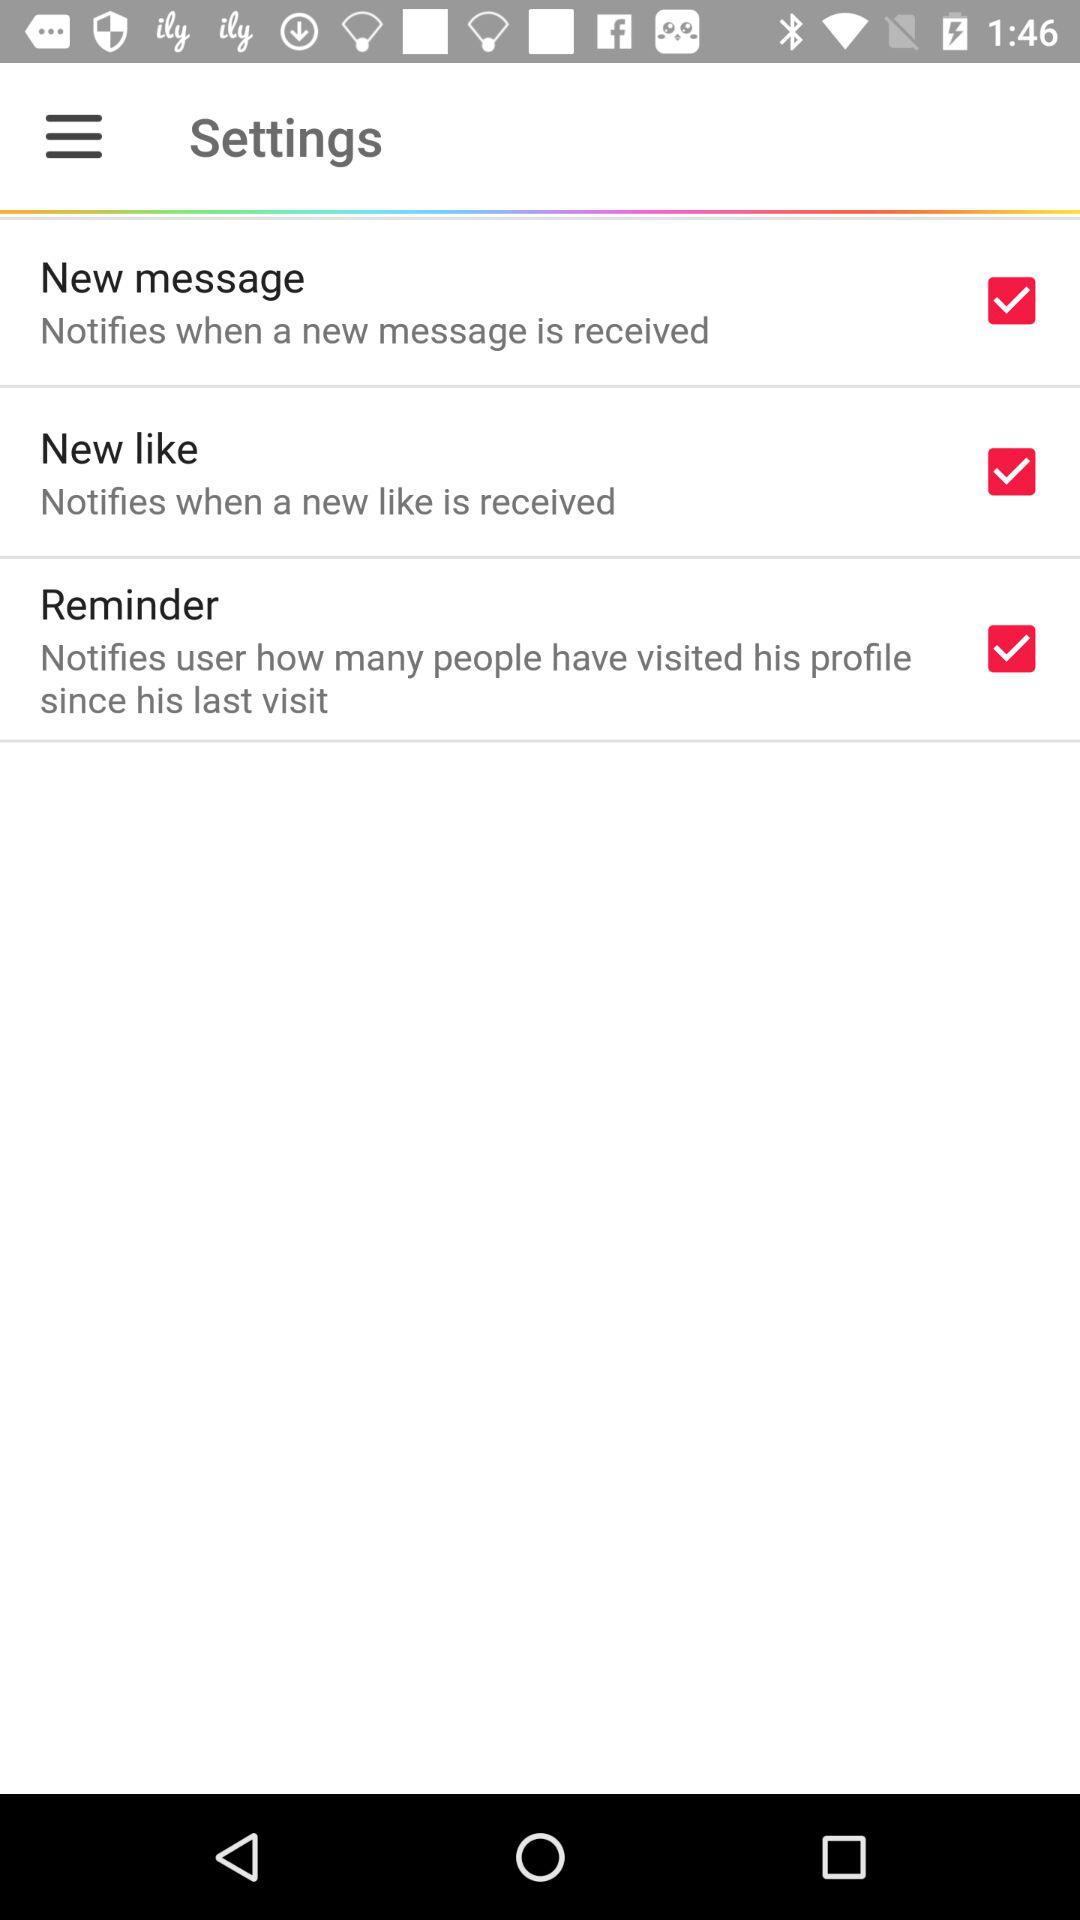What's the status of "New message"? The status is "on". 